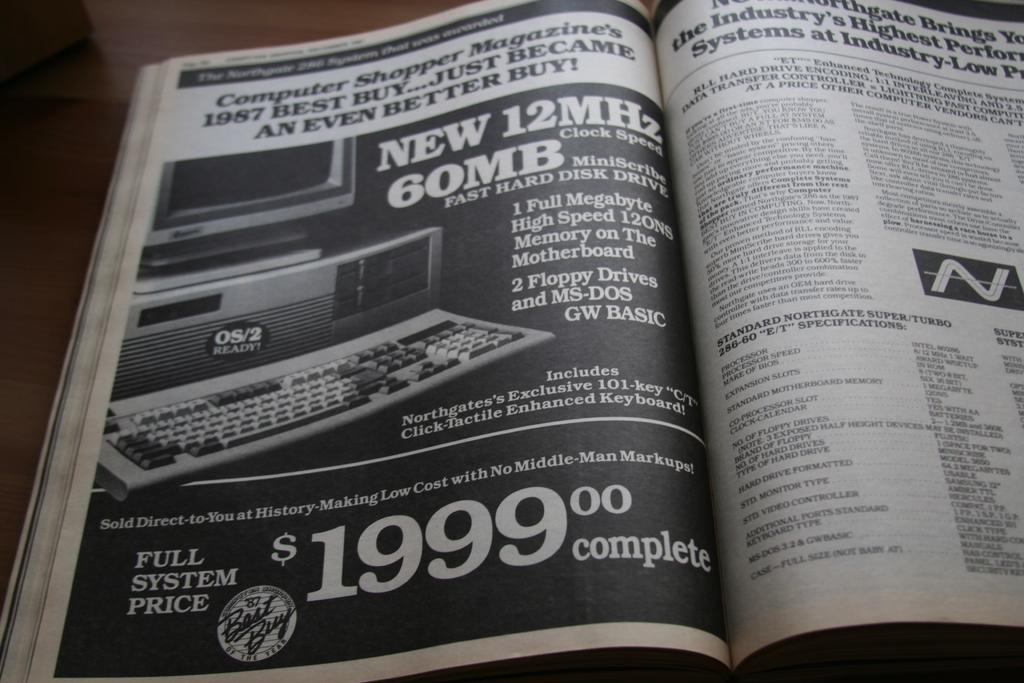<image>
Create a compact narrative representing the image presented. The price for the full system advertised is $1999.00 